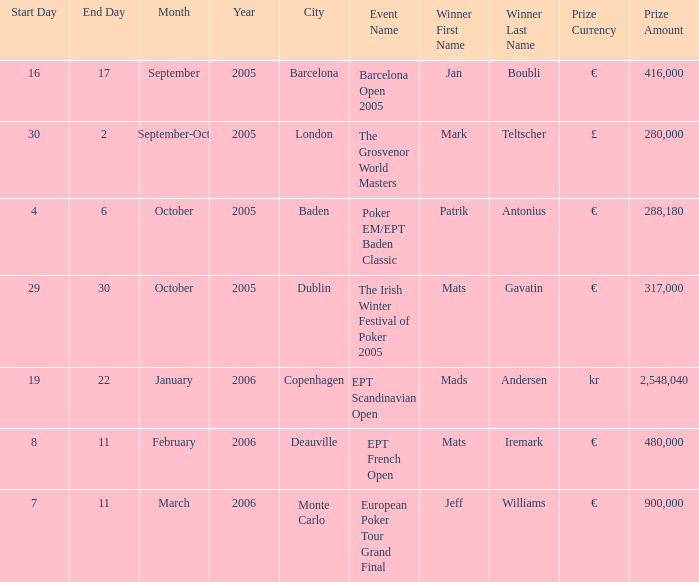For which event was the reward set at €900,000? European Poker Tour Grand Final. 